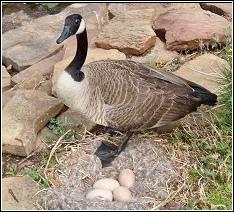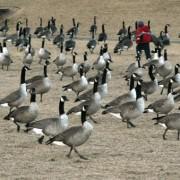The first image is the image on the left, the second image is the image on the right. Assess this claim about the two images: "There are no more than 4 animals in one of the images.". Correct or not? Answer yes or no. Yes. The first image is the image on the left, the second image is the image on the right. Evaluate the accuracy of this statement regarding the images: "There is at least one human pictured with a group of birds.". Is it true? Answer yes or no. Yes. The first image is the image on the left, the second image is the image on the right. For the images shown, is this caption "The left image contains no more than 13 birds." true? Answer yes or no. Yes. 